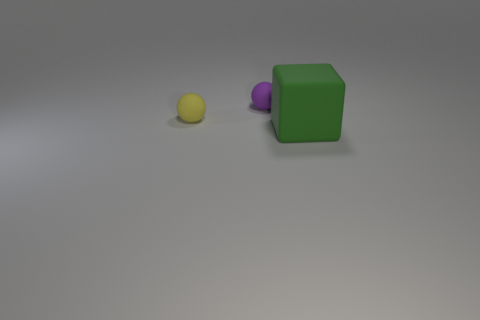Is there anything else that is the same size as the green object?
Provide a short and direct response. No. What number of things are either green rubber things or big green matte cubes on the right side of the small purple rubber object?
Offer a terse response. 1. Is the number of big green blocks right of the yellow object greater than the number of tiny purple spheres that are in front of the matte cube?
Your answer should be very brief. Yes. There is a thing that is right of the sphere right of the rubber thing to the left of the purple matte ball; what shape is it?
Provide a succinct answer. Cube. There is a small matte object that is on the right side of the tiny object that is in front of the purple rubber thing; what shape is it?
Your response must be concise. Sphere. Is there a small thing that has the same material as the big object?
Your answer should be compact. Yes. How many green objects are tiny matte things or cubes?
Give a very brief answer. 1. What size is the yellow ball that is made of the same material as the small purple sphere?
Ensure brevity in your answer.  Small. What number of cubes are either small yellow rubber things or small objects?
Make the answer very short. 0. Are there more purple objects than yellow shiny balls?
Keep it short and to the point. Yes. 